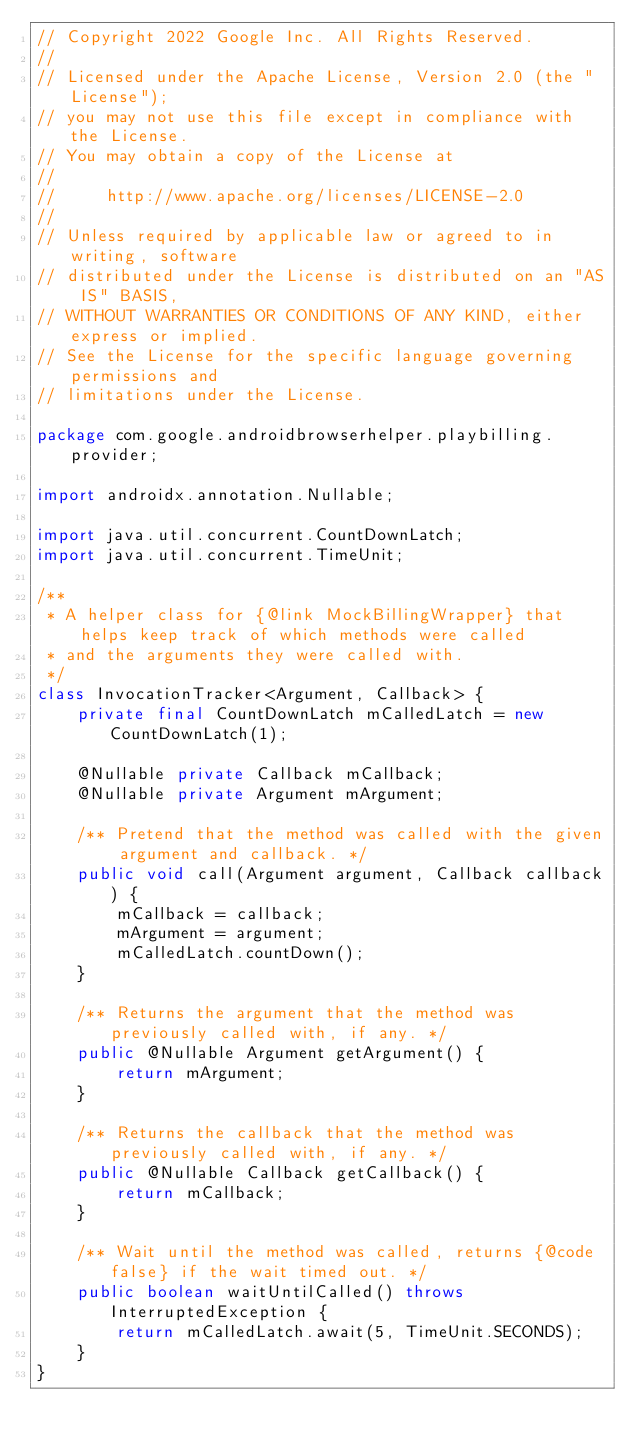Convert code to text. <code><loc_0><loc_0><loc_500><loc_500><_Java_>// Copyright 2022 Google Inc. All Rights Reserved.
//
// Licensed under the Apache License, Version 2.0 (the "License");
// you may not use this file except in compliance with the License.
// You may obtain a copy of the License at
//
//     http://www.apache.org/licenses/LICENSE-2.0
//
// Unless required by applicable law or agreed to in writing, software
// distributed under the License is distributed on an "AS IS" BASIS,
// WITHOUT WARRANTIES OR CONDITIONS OF ANY KIND, either express or implied.
// See the License for the specific language governing permissions and
// limitations under the License.

package com.google.androidbrowserhelper.playbilling.provider;

import androidx.annotation.Nullable;

import java.util.concurrent.CountDownLatch;
import java.util.concurrent.TimeUnit;

/**
 * A helper class for {@link MockBillingWrapper} that helps keep track of which methods were called
 * and the arguments they were called with.
 */
class InvocationTracker<Argument, Callback> {
    private final CountDownLatch mCalledLatch = new CountDownLatch(1);

    @Nullable private Callback mCallback;
    @Nullable private Argument mArgument;

    /** Pretend that the method was called with the given argument and callback. */
    public void call(Argument argument, Callback callback) {
        mCallback = callback;
        mArgument = argument;
        mCalledLatch.countDown();
    }

    /** Returns the argument that the method was previously called with, if any. */
    public @Nullable Argument getArgument() {
        return mArgument;
    }

    /** Returns the callback that the method was previously called with, if any. */
    public @Nullable Callback getCallback() {
        return mCallback;
    }

    /** Wait until the method was called, returns {@code false} if the wait timed out. */
    public boolean waitUntilCalled() throws InterruptedException {
        return mCalledLatch.await(5, TimeUnit.SECONDS);
    }
}
</code> 